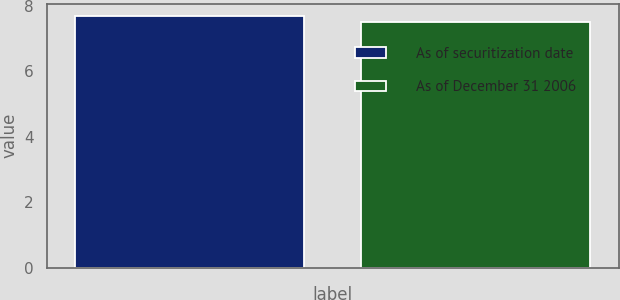Convert chart. <chart><loc_0><loc_0><loc_500><loc_500><bar_chart><fcel>As of securitization date<fcel>As of December 31 2006<nl><fcel>7.68<fcel>7.52<nl></chart> 